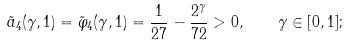Convert formula to latex. <formula><loc_0><loc_0><loc_500><loc_500>\tilde { a } _ { 4 } ( \gamma , 1 ) = \tilde { \varphi } _ { 4 } ( \gamma , 1 ) = \frac { 1 } { 2 7 } - \frac { 2 ^ { \gamma } } { 7 2 } > 0 , \quad \gamma \in [ 0 , 1 ] ;</formula> 